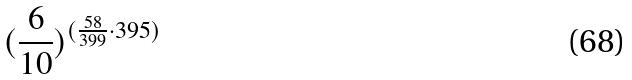Convert formula to latex. <formula><loc_0><loc_0><loc_500><loc_500>( \frac { 6 } { 1 0 } ) ^ { ( \frac { 5 8 } { 3 9 9 } \cdot 3 9 5 ) }</formula> 